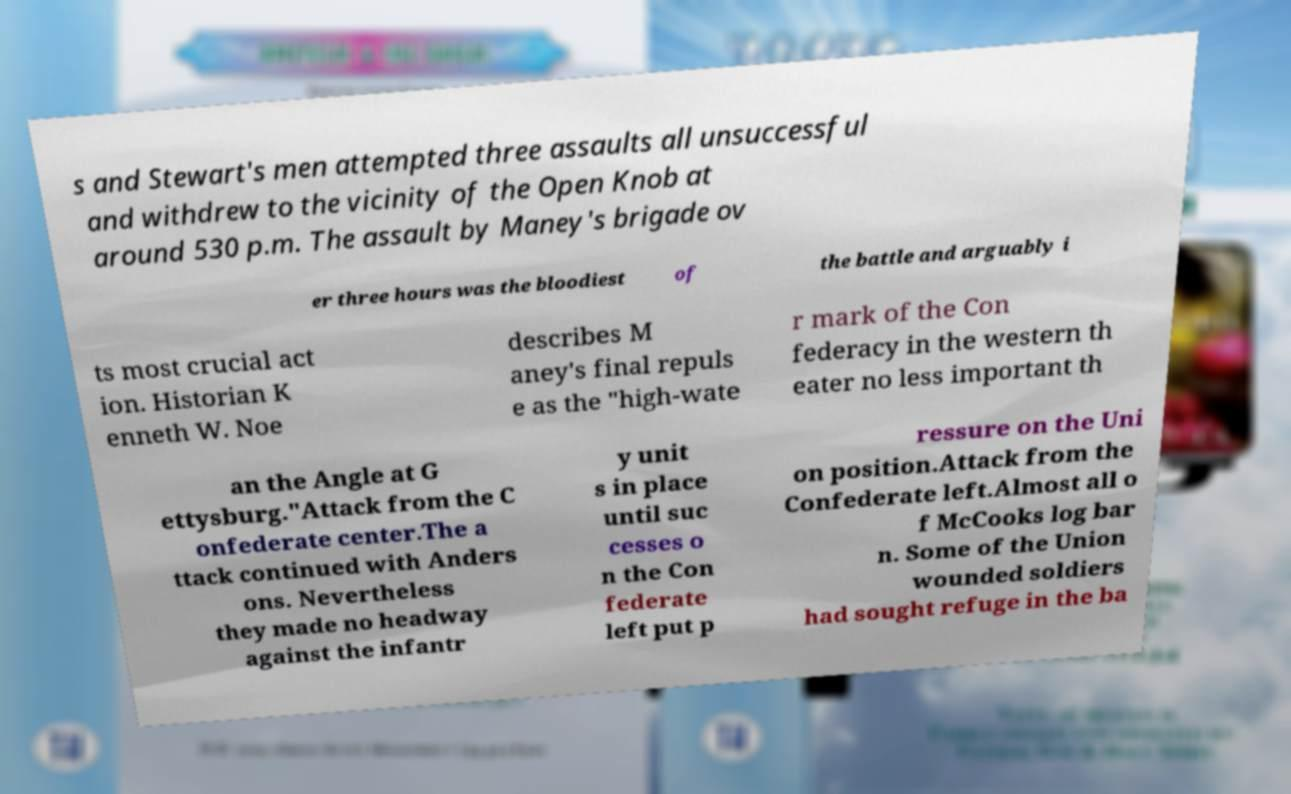Could you assist in decoding the text presented in this image and type it out clearly? s and Stewart's men attempted three assaults all unsuccessful and withdrew to the vicinity of the Open Knob at around 530 p.m. The assault by Maney's brigade ov er three hours was the bloodiest of the battle and arguably i ts most crucial act ion. Historian K enneth W. Noe describes M aney's final repuls e as the "high-wate r mark of the Con federacy in the western th eater no less important th an the Angle at G ettysburg."Attack from the C onfederate center.The a ttack continued with Anders ons. Nevertheless they made no headway against the infantr y unit s in place until suc cesses o n the Con federate left put p ressure on the Uni on position.Attack from the Confederate left.Almost all o f McCooks log bar n. Some of the Union wounded soldiers had sought refuge in the ba 